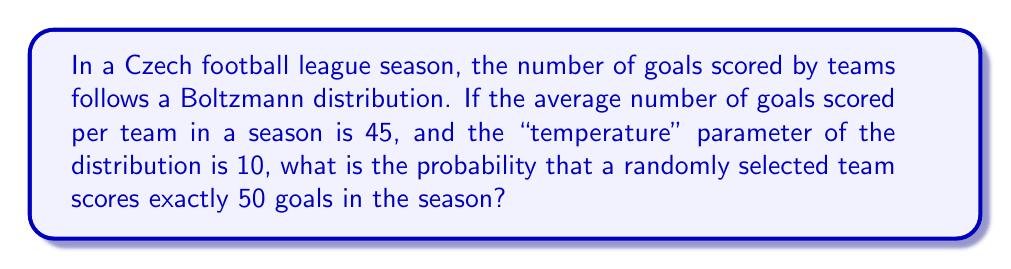Provide a solution to this math problem. To solve this problem, we'll use the Boltzmann distribution and follow these steps:

1) The Boltzmann distribution is given by:

   $$P(E) = \frac{1}{Z} e^{-E/kT}$$

   where $P(E)$ is the probability, $E$ is the energy state (in our case, the number of goals), $k$ is Boltzmann's constant (which we'll set to 1 for simplicity), $T$ is the temperature parameter, and $Z$ is the partition function.

2) We're given that $T = 10$ and the average number of goals $\langle E \rangle = 45$.

3) For the Boltzmann distribution, we know that $\langle E \rangle = kT$. Since we set $k = 1$, this means:

   $$45 = 1 \cdot 10$$

   This confirms our parameters are consistent.

4) Now, we need to calculate the probability for $E = 50$:

   $$P(50) = \frac{1}{Z} e^{-50/10}$$

5) We don't know $Z$, but we can eliminate it by using the normalization condition:

   $$\sum_{E=0}^{\infty} P(E) = 1$$

6) Substituting the Boltzmann distribution:

   $$\sum_{E=0}^{\infty} \frac{1}{Z} e^{-E/10} = 1$$

7) This is a geometric series with $r = e^{-1/10}$. The sum of an infinite geometric series is given by $\frac{1}{1-r}$, so:

   $$\frac{1}{Z} \cdot \frac{1}{1-e^{-1/10}} = 1$$

8) Solving for $Z$:

   $$Z = \frac{1}{1-e^{-1/10}} \approx 10.5171$$

9) Now we can calculate $P(50)$:

   $$P(50) = \frac{1}{10.5171} e^{-50/10} \approx 0.0072$$

Therefore, the probability of a team scoring exactly 50 goals in a season is approximately 0.0072 or 0.72%.
Answer: 0.0072 (or 0.72%) 